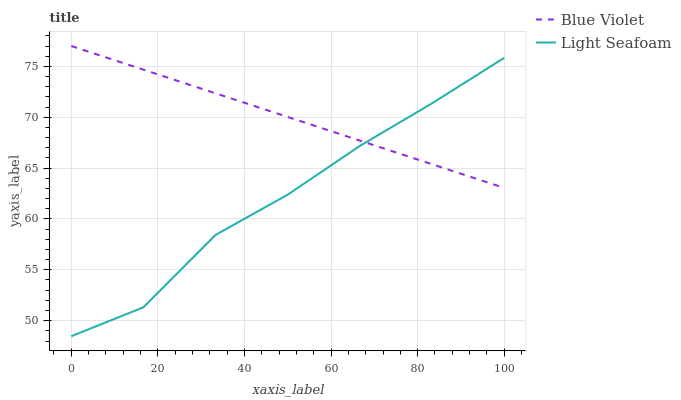Does Light Seafoam have the minimum area under the curve?
Answer yes or no. Yes. Does Blue Violet have the maximum area under the curve?
Answer yes or no. Yes. Does Blue Violet have the minimum area under the curve?
Answer yes or no. No. Is Blue Violet the smoothest?
Answer yes or no. Yes. Is Light Seafoam the roughest?
Answer yes or no. Yes. Is Blue Violet the roughest?
Answer yes or no. No. Does Light Seafoam have the lowest value?
Answer yes or no. Yes. Does Blue Violet have the lowest value?
Answer yes or no. No. Does Blue Violet have the highest value?
Answer yes or no. Yes. Does Light Seafoam intersect Blue Violet?
Answer yes or no. Yes. Is Light Seafoam less than Blue Violet?
Answer yes or no. No. Is Light Seafoam greater than Blue Violet?
Answer yes or no. No. 